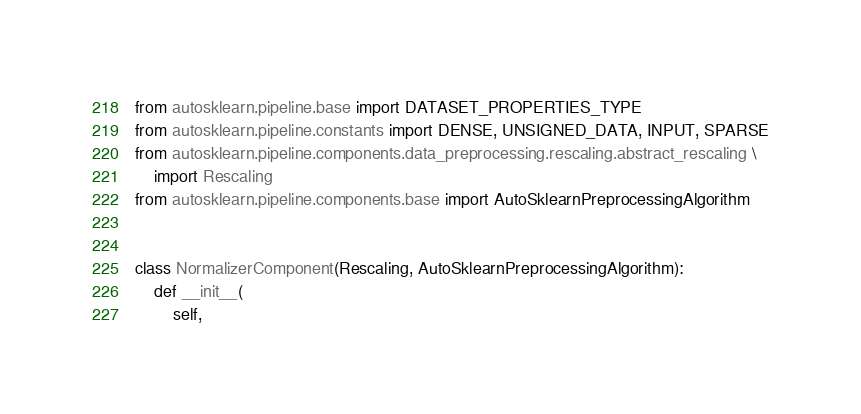<code> <loc_0><loc_0><loc_500><loc_500><_Python_>from autosklearn.pipeline.base import DATASET_PROPERTIES_TYPE
from autosklearn.pipeline.constants import DENSE, UNSIGNED_DATA, INPUT, SPARSE
from autosklearn.pipeline.components.data_preprocessing.rescaling.abstract_rescaling \
    import Rescaling
from autosklearn.pipeline.components.base import AutoSklearnPreprocessingAlgorithm


class NormalizerComponent(Rescaling, AutoSklearnPreprocessingAlgorithm):
    def __init__(
        self,</code> 